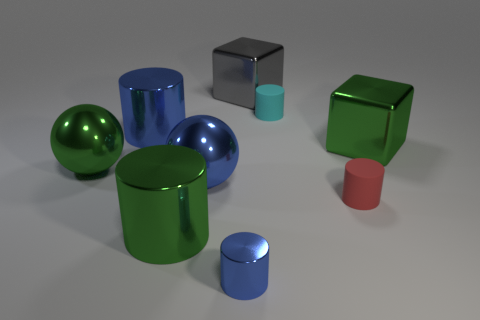Do the small red matte object and the small cyan thing have the same shape?
Provide a short and direct response. Yes. How many cylinders are big yellow metal objects or blue objects?
Provide a short and direct response. 2. What color is the tiny cylinder that is made of the same material as the cyan object?
Offer a terse response. Red. Is the size of the cylinder that is on the left side of the green cylinder the same as the blue metal ball?
Provide a short and direct response. Yes. Is the material of the big green cube the same as the blue cylinder that is on the left side of the tiny blue shiny object?
Make the answer very short. Yes. The object on the left side of the large blue cylinder is what color?
Offer a terse response. Green. Are there any big objects that are right of the tiny cylinder to the left of the big gray thing?
Your answer should be compact. Yes. There is a tiny matte cylinder that is to the right of the tiny cyan matte thing; does it have the same color as the big metallic block in front of the big gray metal object?
Provide a succinct answer. No. There is a gray shiny object; what number of green metallic cylinders are in front of it?
Provide a short and direct response. 1. What number of large shiny cylinders are the same color as the tiny shiny thing?
Make the answer very short. 1. 